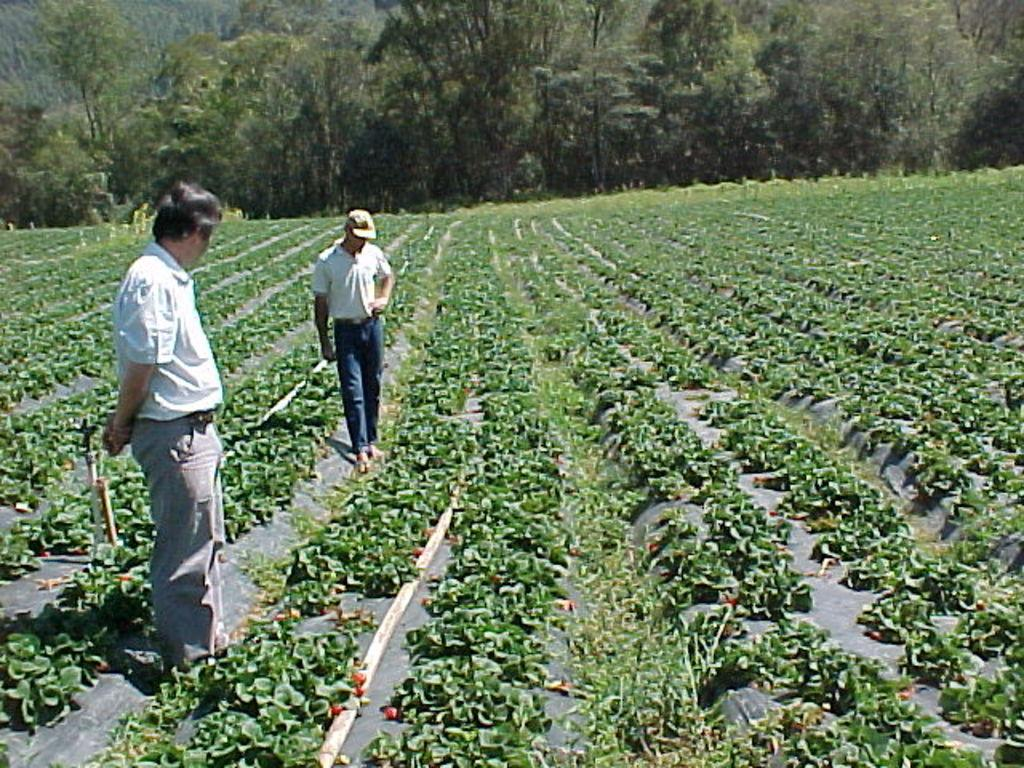How many people are present in the image? There are two people standing in the image. What type of vegetation can be seen in the image? There are green plants and trees visible in the image. What type of bead is being used to decorate the field in the image? There is no field or bead present in the image. What is the purpose of the pan in the image? There is no pan present in the image. 